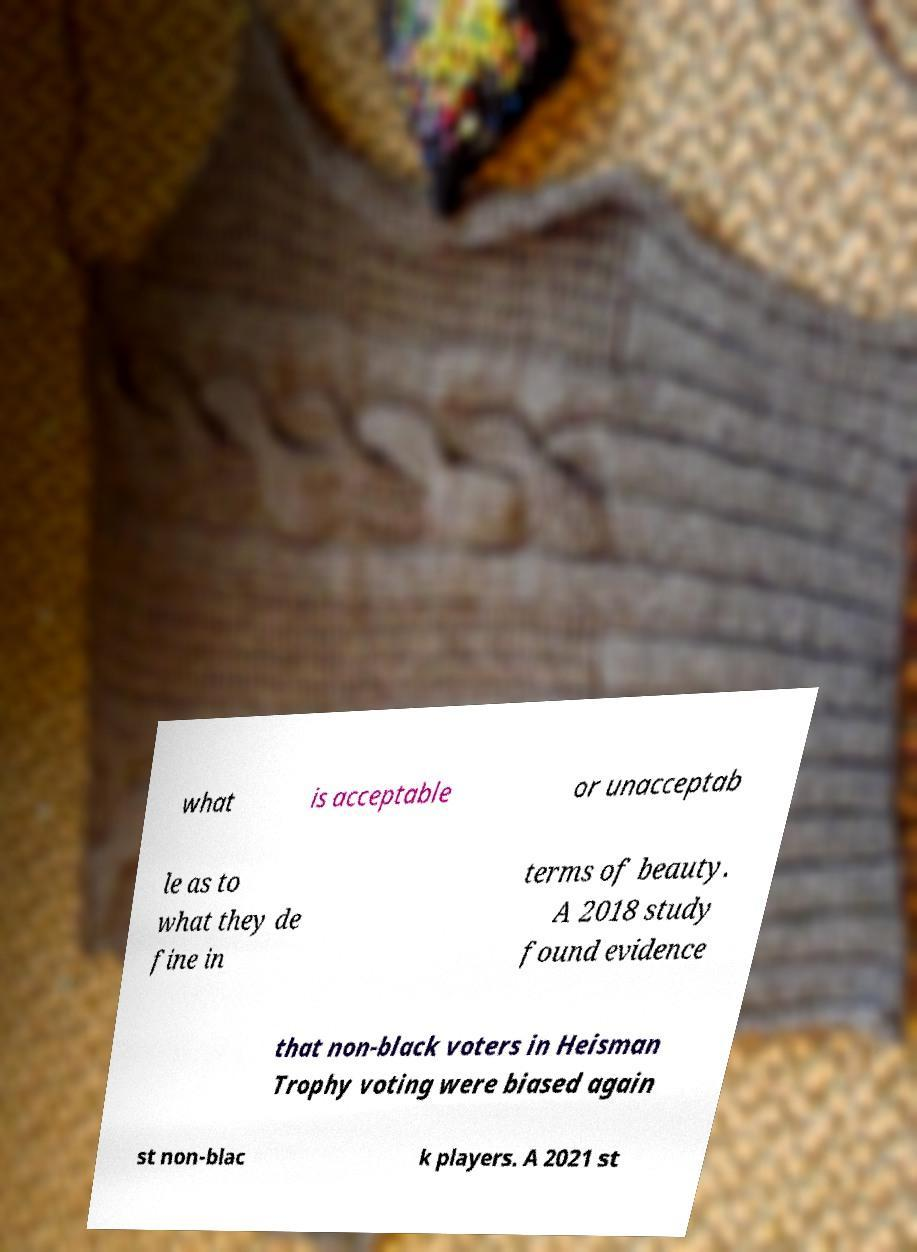For documentation purposes, I need the text within this image transcribed. Could you provide that? what is acceptable or unacceptab le as to what they de fine in terms of beauty. A 2018 study found evidence that non-black voters in Heisman Trophy voting were biased again st non-blac k players. A 2021 st 